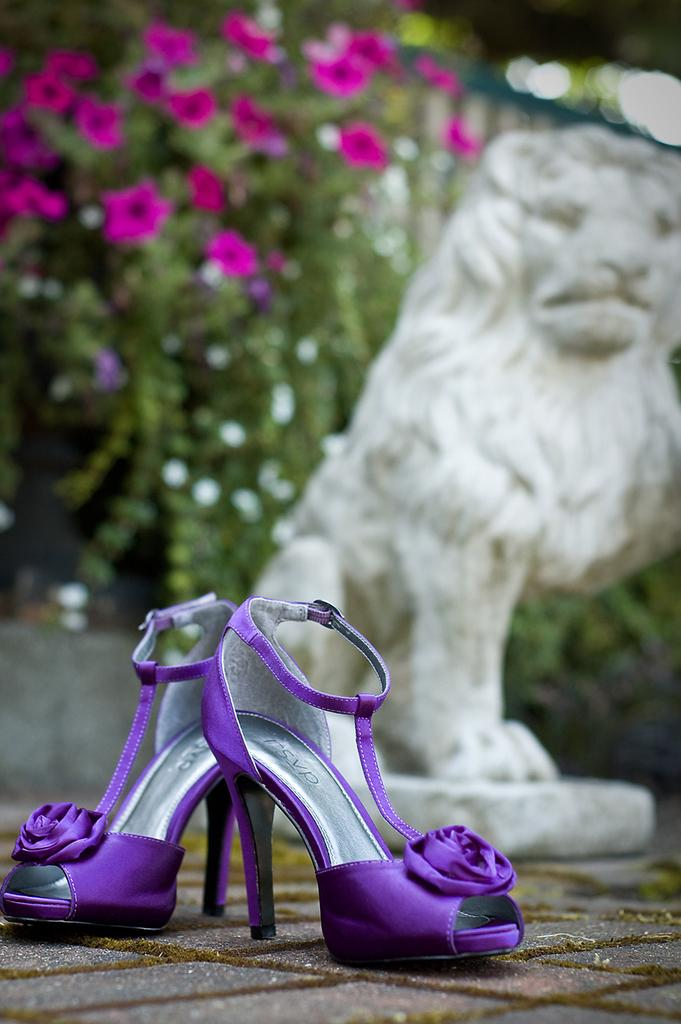What type of footwear is featured in the image? There are heels in the image. What can be seen behind the heels? There is a statue behind the heels. What type of vegetation is visible in the background of the image? There are plants and flowers in the background of the image. What type of coil is wrapped around the statue in the image? There is no coil present in the image; the statue is not wrapped in any coil. 